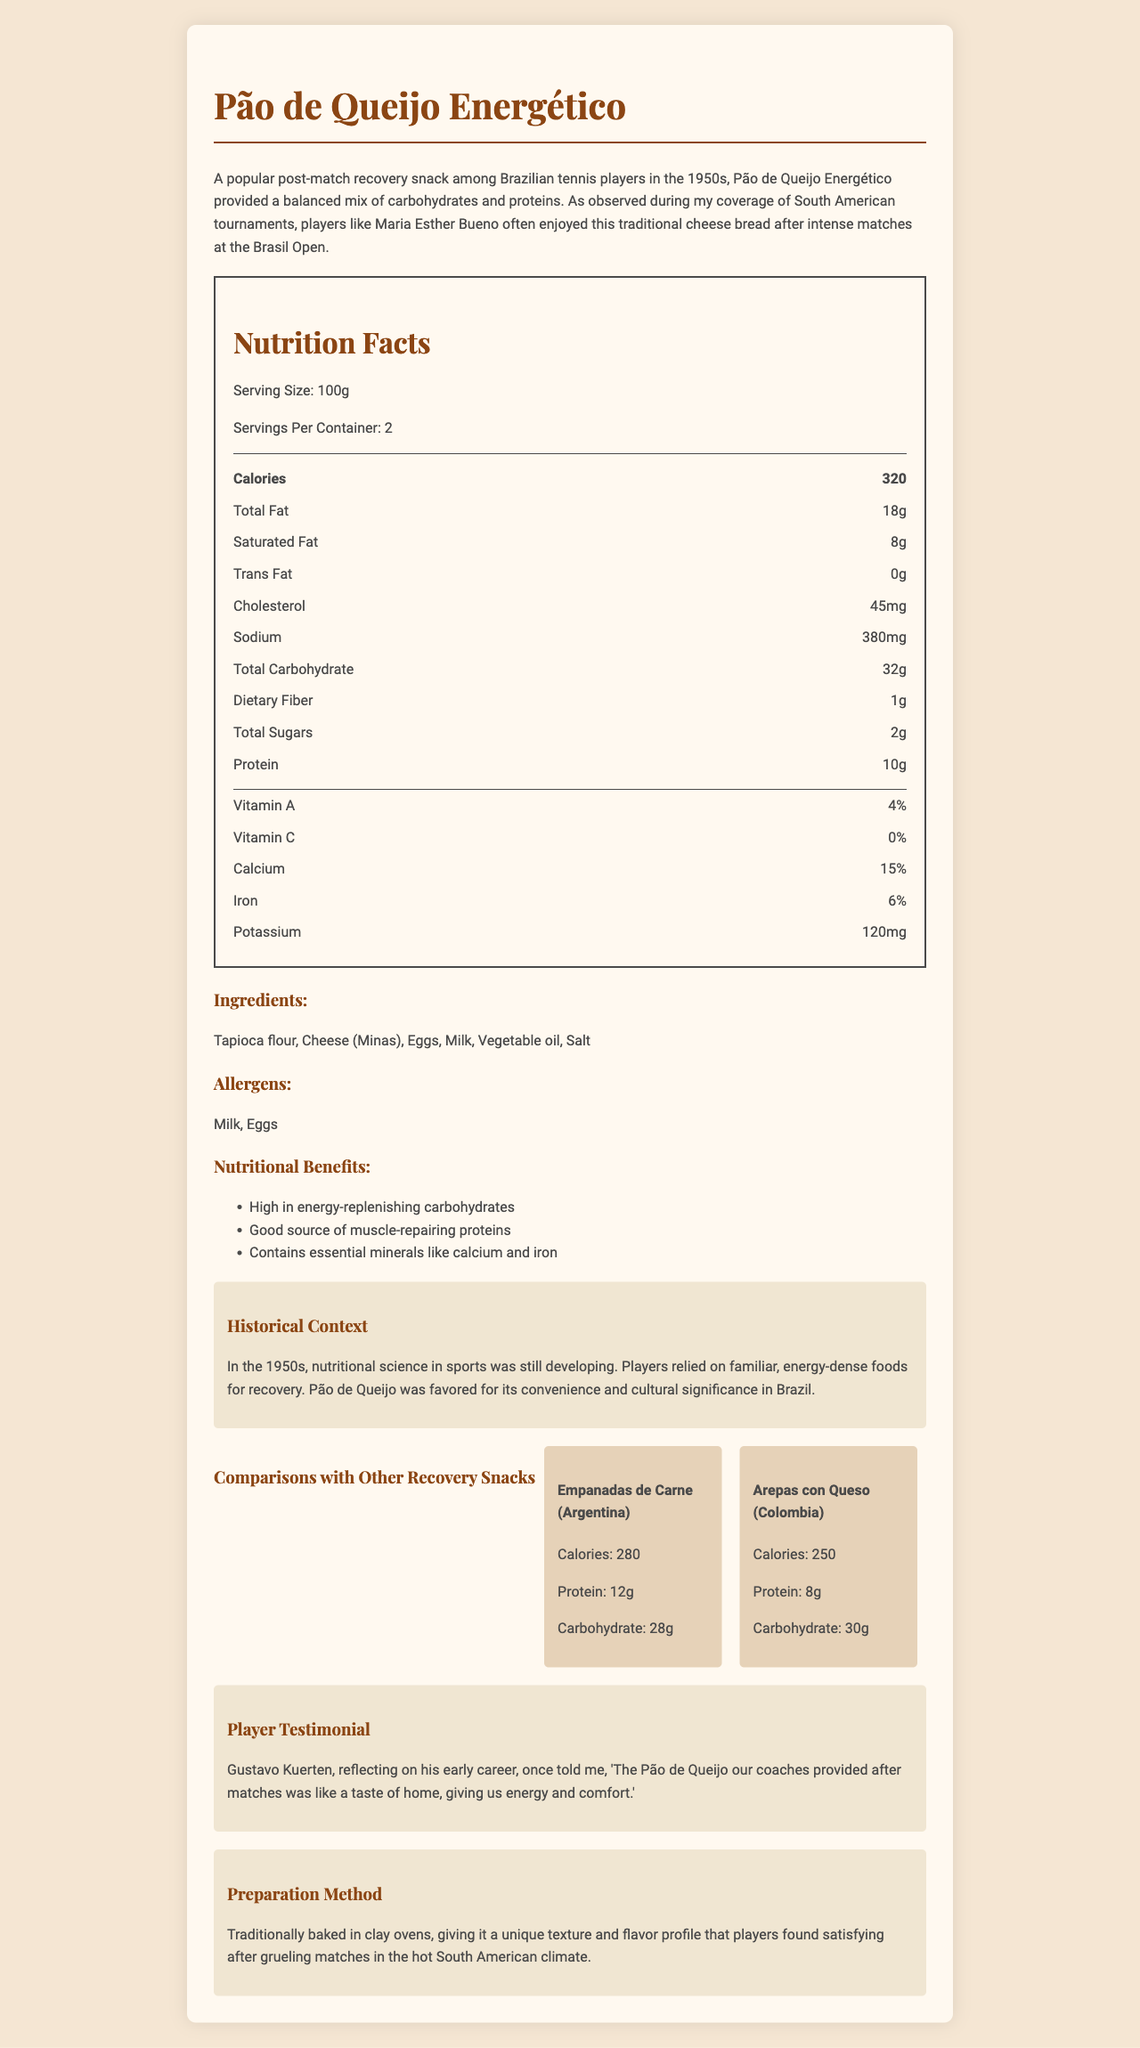what is the serving size for Pão de Queijo Energético? The serving size is clearly mentioned in the Nutrition Facts section as 100g.
Answer: 100g how many servings are in a container of Pão de Queijo Energético? The document says there are 2 servings per container.
Answer: 2 how much protein does one serving of Pão de Queijo Energético provide? According to the Nutrition Facts section, 10g of protein is provided per serving.
Answer: 10g what are the main ingredients in Pão de Queijo Energético? The main ingredients are listed under the Ingredients section.
Answer: Tapioca flour, Cheese (Minas), Eggs, Milk, Vegetable oil, Salt Which vitamins are present in Pão de Queijo Energético? The vitamins are listed in the Nutrition Facts section.
Answer: Vitamin A, Vitamin C Which ingredients in Pão de Queijo Energético could cause allergies? A. Milk and Sugar B. Eggs and Milk C. Wheat and Nuts The Allergen section specifically mentions Milk and Eggs.
Answer: B How many grams of saturated fat are in one serving of Pão de Queijo Energético? The Nutrition Facts section lists 8g of saturated fat per serving.
Answer: 8g What is the historical context of Pão de Queijo Energético being used as a recovery snack? The Historical Context section provides this information.
Answer: In the 1950s, nutritional science in sports was still developing, and players relied on familiar, energy-dense foods for recovery. Pão de Queijo was favored for its convenience and cultural significance in Brazil. Is there any trans fat in Pão de Queijo Energético? The Nutrition Facts section lists 0g of trans fat.
Answer: No Who is a notable tennis player mentioned in the document that enjoyed Pão de Queijo Energético? A. Gustavo Kuerten B. Juan Martin del Potro C. Maria Esther Bueno The description mentions that Maria Esther Bueno enjoyed Pão de Queijo Energético.
Answer: C How many calories are in one serving of Pão de Queijo Energético? The Nutrition Facts section mentions 320 calories per serving.
Answer: 320 calories What is Gustavo Kuerten's opinion on Pão de Queijo Energético? The Player Testimonial section states Kuerten’s thoughts on the snack.
Answer: He reflected on it as a taste of home that provided energy and comfort after matches. Summarize the main idea of the document. The document focuses on the nutritional content, history, cultural significance, and preparation of Pão de Queijo Energético, making it a favored choice for energy replenishment.
Answer: The document provides a detailed analysis of Pão de Queijo Energético, a popular post-match recovery snack among Brazilian tennis players in the 1950s. It includes nutritional facts, ingredients, potential allergens, historical context, player testimonials, comparisons with other snacks, and preparation methods. What percentage of daily calcium does Pão de Queijo Energético provide? The Nutrition Facts section lists the calcium content as 15%.
Answer: 15% How are Pão de Queijo traditionally prepared? The Preparation Method section details that they are traditionally baked in clay ovens.
Answer: Baked in clay ovens Which snack from the comparison section has the highest protein content? The comparisons section lists Empanadas de Carne with 12g of protein, higher than the 8g in Arepas con Queso.
Answer: Empanadas de Carne Was Juan Martin del Potro mentioned as enjoying Pão de Queijo Energético? The document does not mention Juan Martin del Potro in relation to Pão de Queijo Energético.
Answer: No 